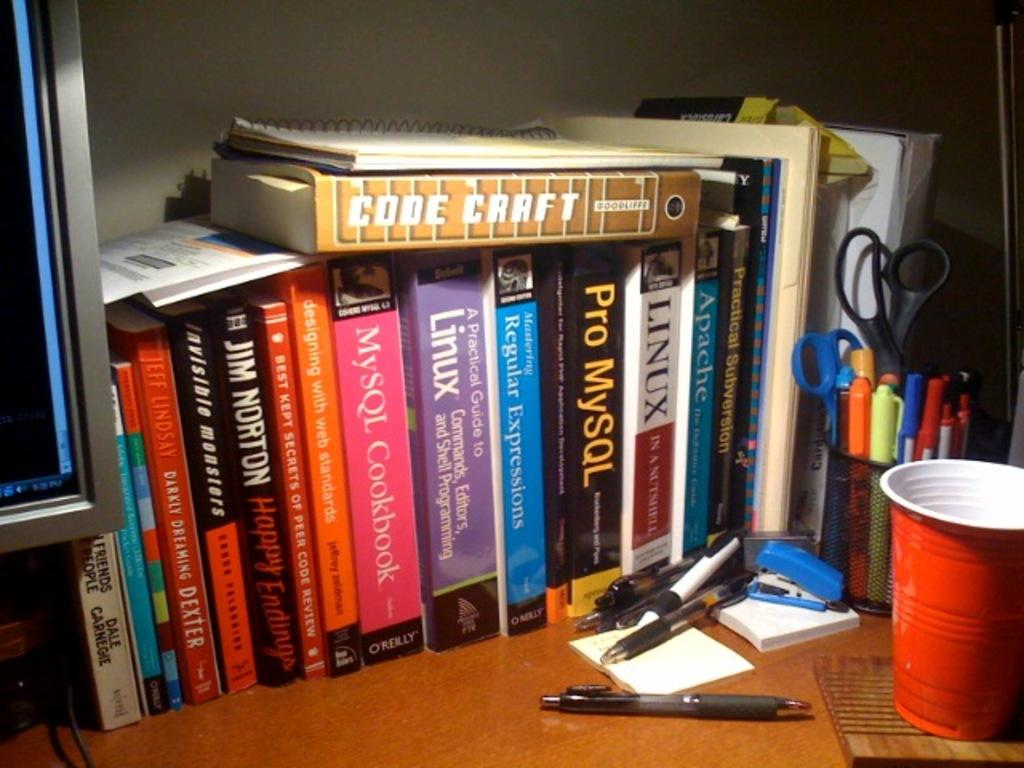<image>
Render a clear and concise summary of the photo. Shelf full of books including one that says Pro MySQL. 